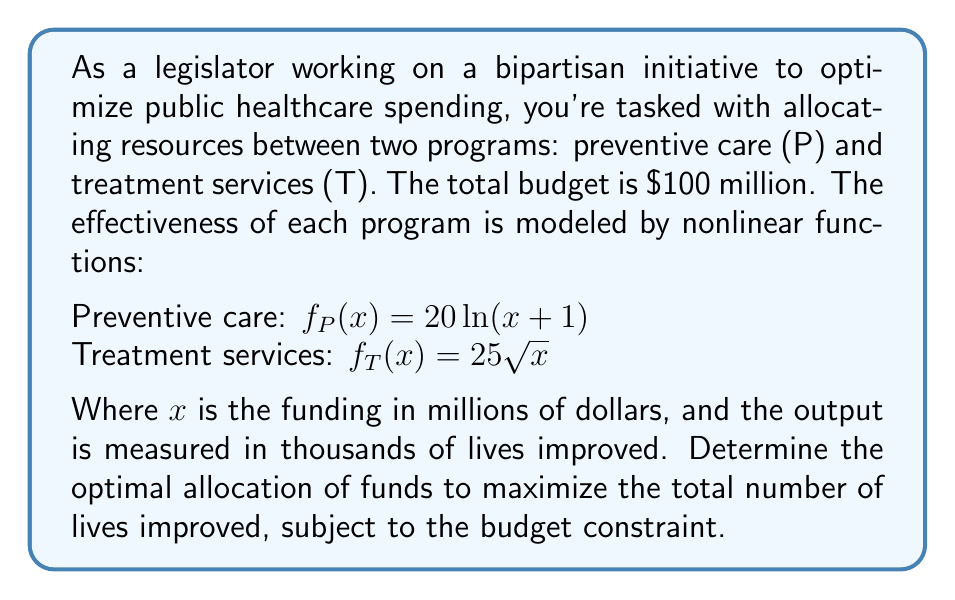Teach me how to tackle this problem. To solve this nonlinear programming problem, we'll use the method of Lagrange multipliers:

1) Define the objective function:
   $$ F(x, y) = 20\ln(x+1) + 25\sqrt{y} $$
   where $x$ is funding for preventive care and $y$ for treatment services.

2) The constraint is:
   $$ x + y = 100 $$

3) Form the Lagrangian:
   $$ L(x, y, \lambda) = 20\ln(x+1) + 25\sqrt{y} + \lambda(100 - x - y) $$

4) Set partial derivatives to zero:
   $$ \frac{\partial L}{\partial x} = \frac{20}{x+1} - \lambda = 0 $$
   $$ \frac{\partial L}{\partial y} = \frac{25}{2\sqrt{y}} - \lambda = 0 $$
   $$ \frac{\partial L}{\partial \lambda} = 100 - x - y = 0 $$

5) From the first two equations:
   $$ \frac{20}{x+1} = \frac{25}{2\sqrt{y}} $$

6) Simplify:
   $$ 40\sqrt{y} = 25(x+1) $$
   $$ y = \frac{625(x+1)^2}{1600} $$

7) Substitute into the constraint:
   $$ x + \frac{625(x+1)^2}{1600} = 100 $$

8) Solve numerically (using a computer or calculator):
   $$ x \approx 36.84 $$
   $$ y \approx 63.16 $$

9) Verify the solution satisfies the constraint:
   $$ 36.84 + 63.16 = 100 $$

Therefore, the optimal allocation is approximately $36.84 million for preventive care and $63.16 million for treatment services.
Answer: Preventive care: $36.84 million; Treatment services: $63.16 million 